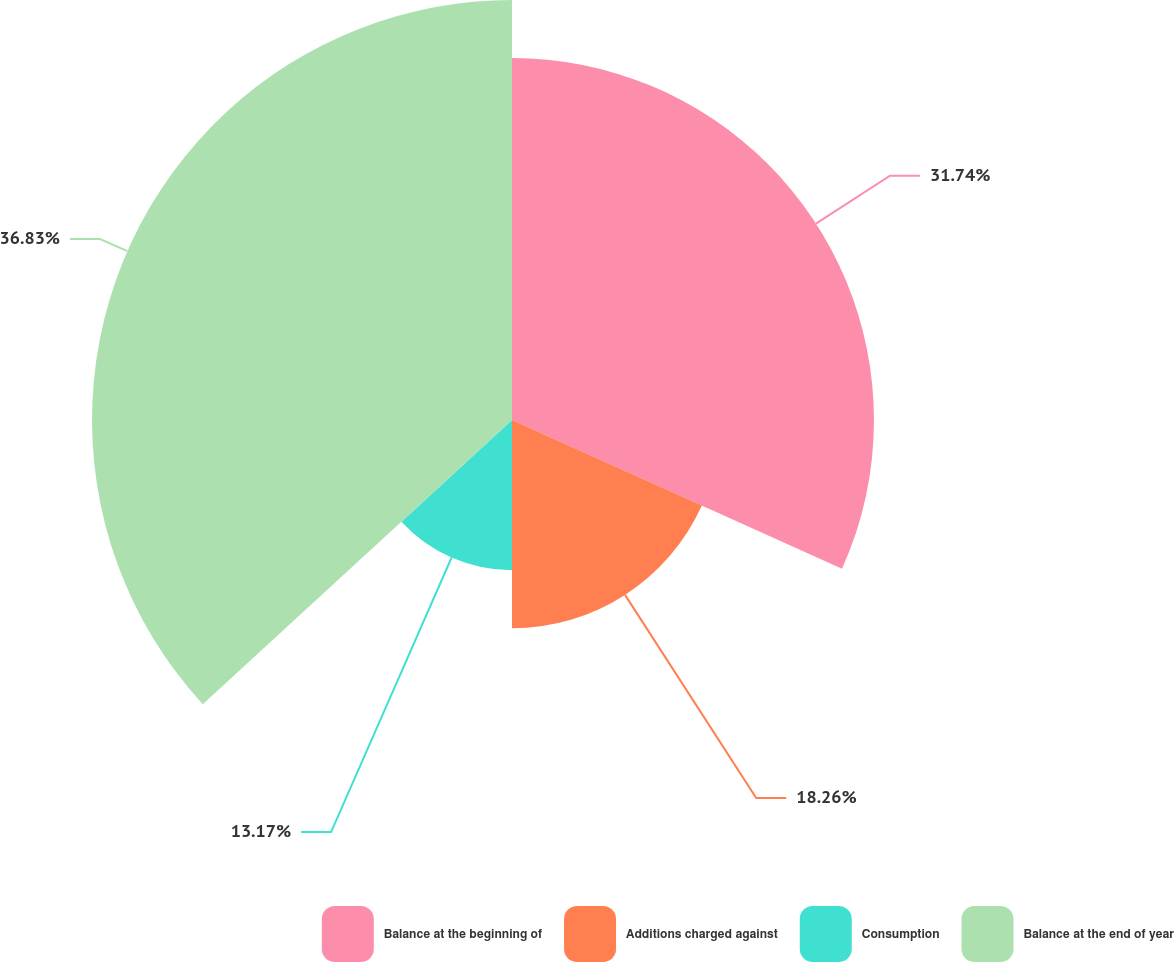Convert chart. <chart><loc_0><loc_0><loc_500><loc_500><pie_chart><fcel>Balance at the beginning of<fcel>Additions charged against<fcel>Consumption<fcel>Balance at the end of year<nl><fcel>31.74%<fcel>18.26%<fcel>13.17%<fcel>36.83%<nl></chart> 